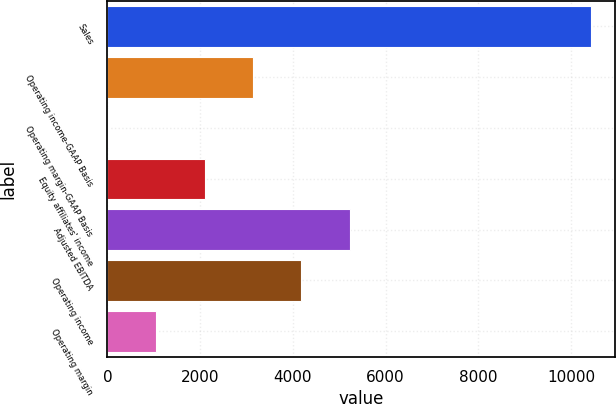<chart> <loc_0><loc_0><loc_500><loc_500><bar_chart><fcel>Sales<fcel>Operating income-GAAP Basis<fcel>Operating margin-GAAP Basis<fcel>Equity affiliates' income<fcel>Adjusted EBITDA<fcel>Operating income<fcel>Operating margin<nl><fcel>10439<fcel>3140.59<fcel>12.7<fcel>2097.96<fcel>5225.85<fcel>4183.22<fcel>1055.33<nl></chart> 